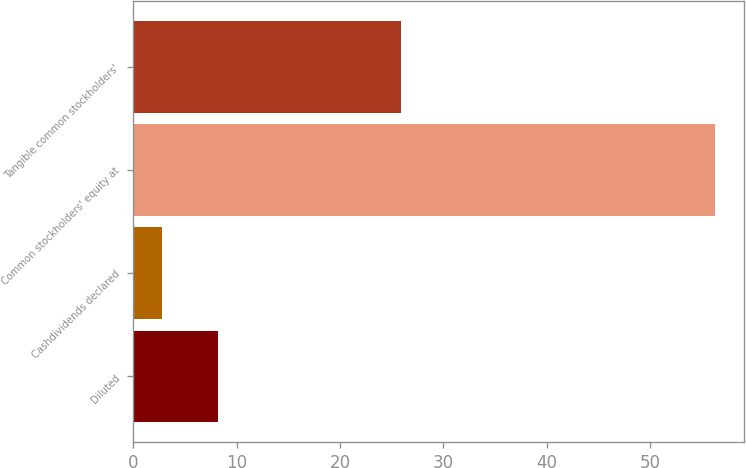Convert chart to OTSL. <chart><loc_0><loc_0><loc_500><loc_500><bar_chart><fcel>Diluted<fcel>Cashdividends declared<fcel>Common stockholders' equity at<fcel>Tangible common stockholders'<nl><fcel>8.15<fcel>2.8<fcel>56.29<fcel>25.94<nl></chart> 